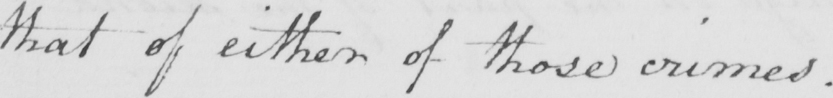What text is written in this handwritten line? that of either of those crimes . 